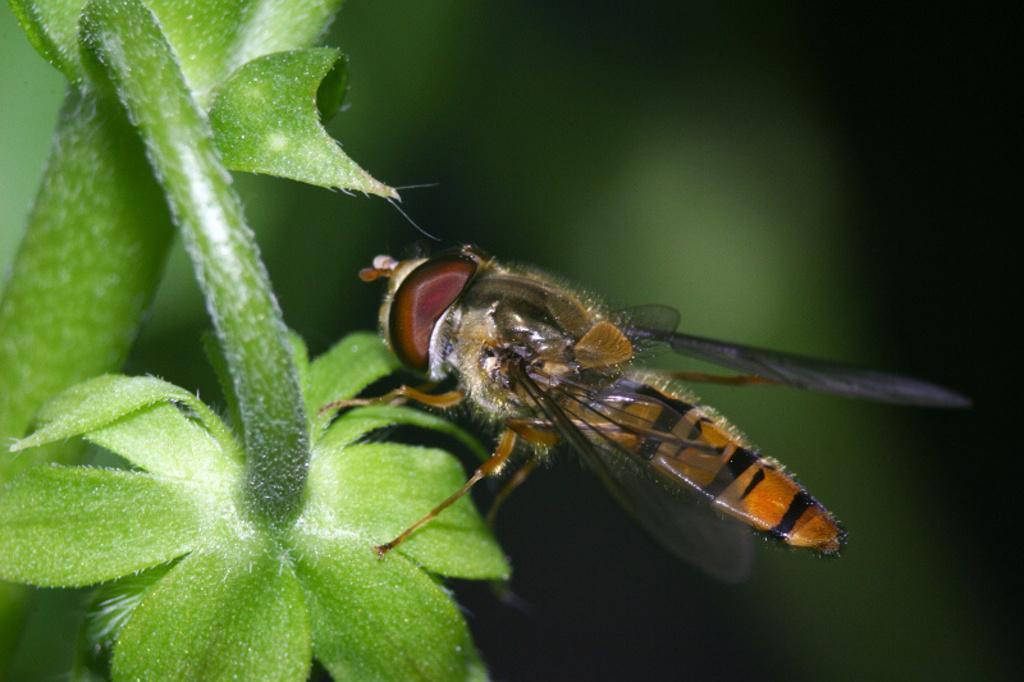Could you give a brief overview of what you see in this image? In this image, we can see an insect on the plant. We can also see the blurred background. 